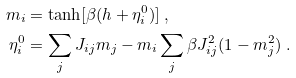<formula> <loc_0><loc_0><loc_500><loc_500>m _ { i } & = \tanh [ \beta ( h + \eta _ { i } ^ { 0 } ) ] \ , \\ \eta _ { i } ^ { 0 } & = \sum _ { j } J _ { i j } m _ { j } - m _ { i } \sum _ { j } \beta J _ { i j } ^ { 2 } ( 1 - m _ { j } ^ { 2 } ) \ .</formula> 